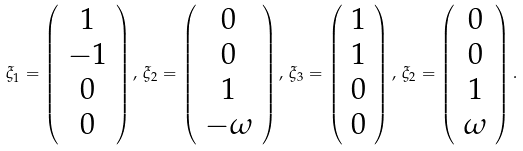<formula> <loc_0><loc_0><loc_500><loc_500>\xi _ { 1 } = \left ( \begin{array} { c } 1 \\ - 1 \\ 0 \\ 0 \end{array} \right ) , \, \xi _ { 2 } = \left ( \begin{array} { c } 0 \\ 0 \\ 1 \\ - \omega \end{array} \right ) , \, \xi _ { 3 } = \left ( \begin{array} { c } 1 \\ 1 \\ 0 \\ 0 \end{array} \right ) , \, \xi _ { 2 } = \left ( \begin{array} { c } 0 \\ 0 \\ 1 \\ \omega \end{array} \right ) .</formula> 